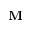<formula> <loc_0><loc_0><loc_500><loc_500>\mathbf M</formula> 